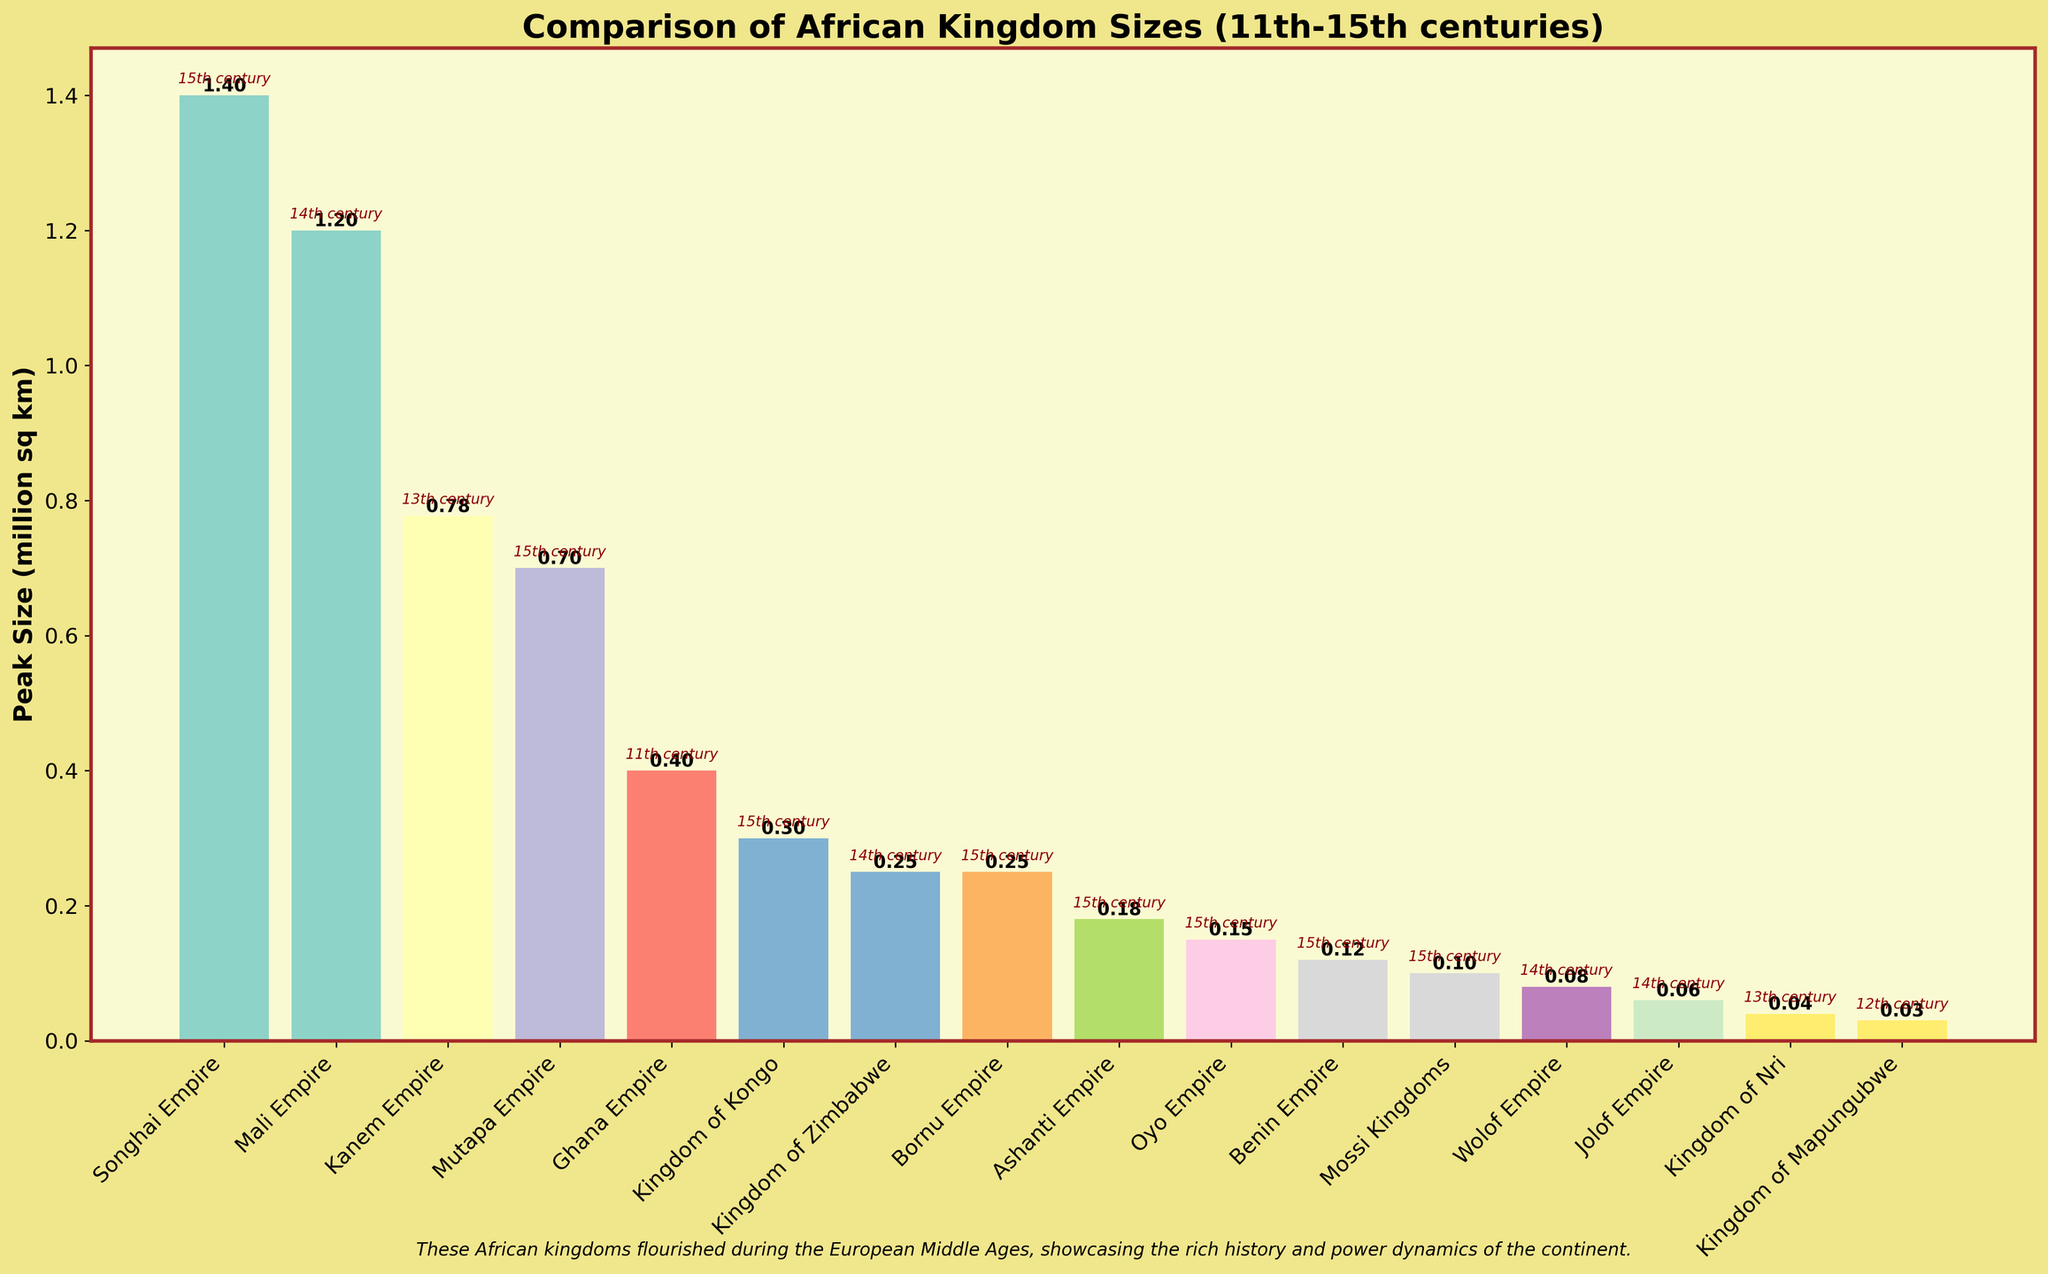Which kingdom had the largest peak size? The largest peak size can be determined by observing the height of the bars. The Songhai Empire has the tallest bar, indicating it had the largest peak size.
Answer: Songhai Empire Which kingdom's peak size was exactly 1 million square kilometers? From the bar labels and heights, the Mali Empire’s bar is labelled with a peak size of 1.20 million square kilometers.
Answer: Mali Empire Compare the peak sizes of the Ghana Empire and the Wolof Empire. Which one was larger? By comparing the heights of the two bars, the Ghana Empire's bar (0.40 million sq km) is taller than the Wolof Empire's (0.08 million sq km).
Answer: Ghana Empire How many kingdoms had a peak size exceeding 0.5 million square kilometers? Counting the bars that exceed 0.5 on the y-axis, we see that the Songhai Empire, Mali Empire, Kanem Empire, and Mutapa Empire all had peak sizes exceeding 0.5 million square kilometers.
Answer: 4 What is the total peak size of kingdoms that flourished in the 15th century? Summing up the peak sizes of the Songhai Empire, Benin Empire, Kingdom of Kongo, Oyo Empire, Mossi Kingdoms, Bornu Empire, Ashanti Empire, and Mutapa Empire, we get: 1.40 + 0.12 + 0.30 + 0.15 + 0.10 + 0.25 + 0.18 + 0.70 = 3.20 million square kilometers.
Answer: 3.20 million sq km Which century features the most kingdoms displayed in the chart? By examining the annotations, it's clear that the 15th century has the most kingdom annotations.
Answer: 15th century Which kingdom had the smallest peak size, and what was it? The Kingdom of Mapungubwe has the shortest bar, labeled with a peak size of 0.03 million square kilometers.
Answer: Kingdom of Mapungubwe, 0.03 million sq km How does the peak size of the Kingdom of Zimbabwe compare to that of the Kingdom of Zimbabwe? The bar for the Kingdom of Nri (0.04 million sq km) is shorter than the bar for the Kingdom of Zimbabwe (0.25 million sq km).
Answer: Kingdom of Zimbabwe is larger Calculate the average peak size of all kingdoms listed. Adding all the peak sizes: 1.20 + 1.40 + 0.40 + 0.12 + 0.776996 + 0.30 + 0.15 + 0.25 + 0.10 + 0.08 + 0.25 + 0.18 + 0.03 + 0.04 + 0.06 + 0.70 = 6.998996 million sq km. Dividing by 16 kingdoms gives an average of 6.998996 / 16 ≈ 0.43743725 million sq km.
Answer: 0.44 million sq km 